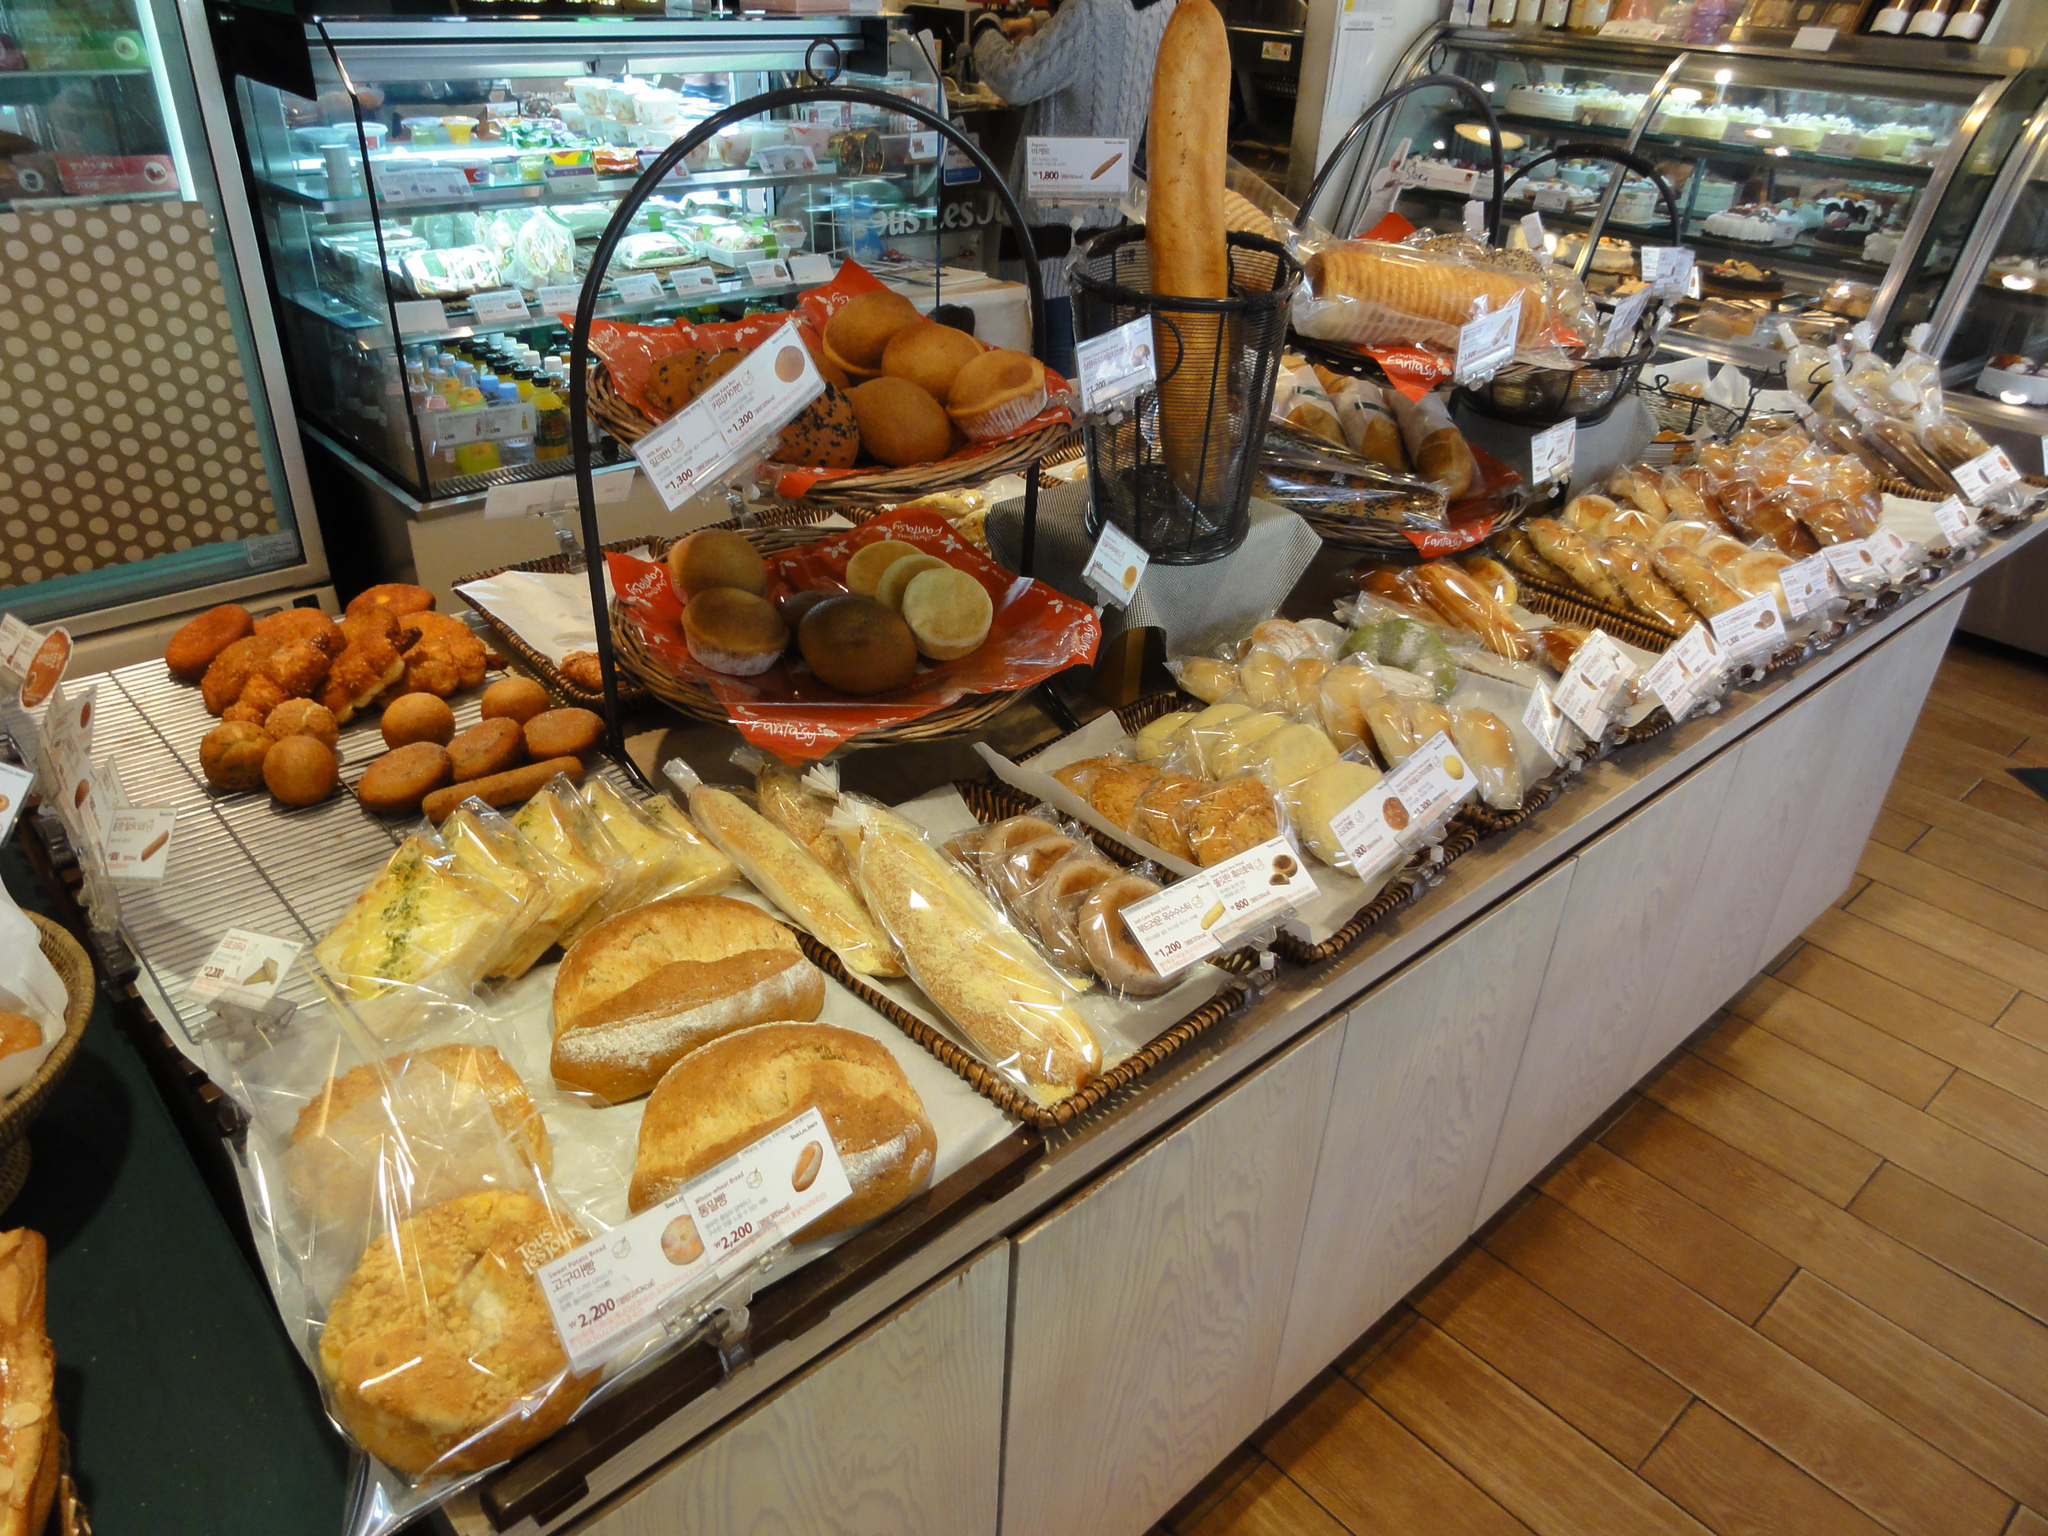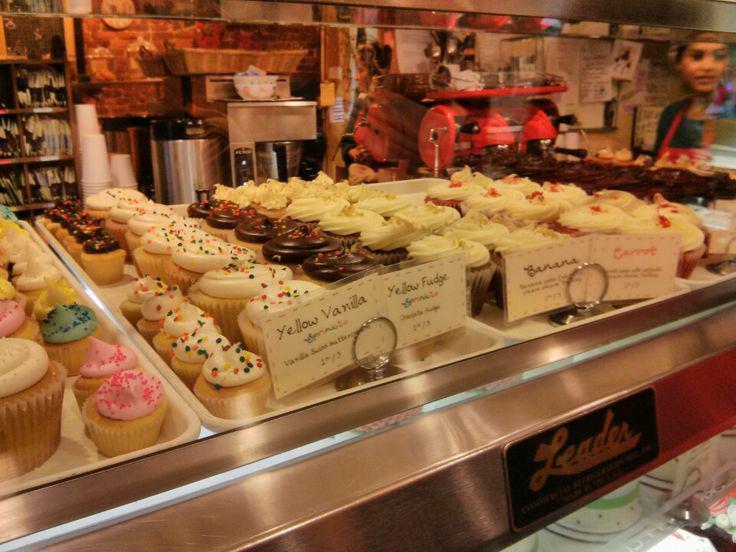The first image is the image on the left, the second image is the image on the right. For the images shown, is this caption "The left image shows decorated cakes on at least the top row of a glass case, and the decorations include upright chocolate shapes." true? Answer yes or no. No. The first image is the image on the left, the second image is the image on the right. Evaluate the accuracy of this statement regarding the images: "Some items are wrapped in clear plastic.". Is it true? Answer yes or no. Yes. 